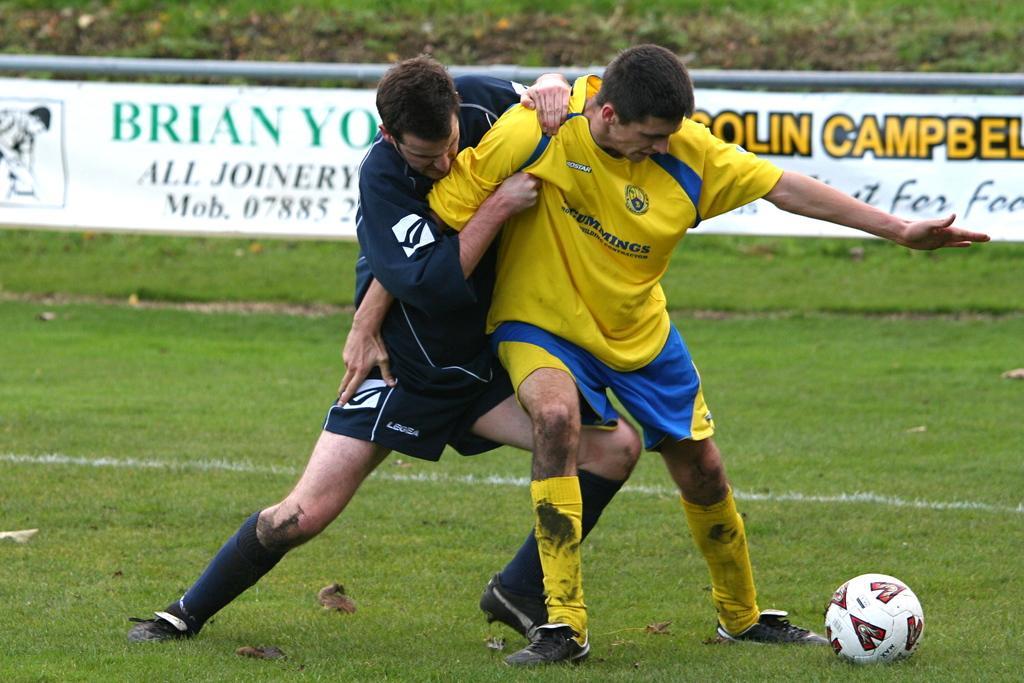Please provide a concise description of this image. In the image we can see two men wearing clothes, socks and shoes, it looks like they are fighting. Here we can see the ball, grass, poster and on the poster there is a text. 